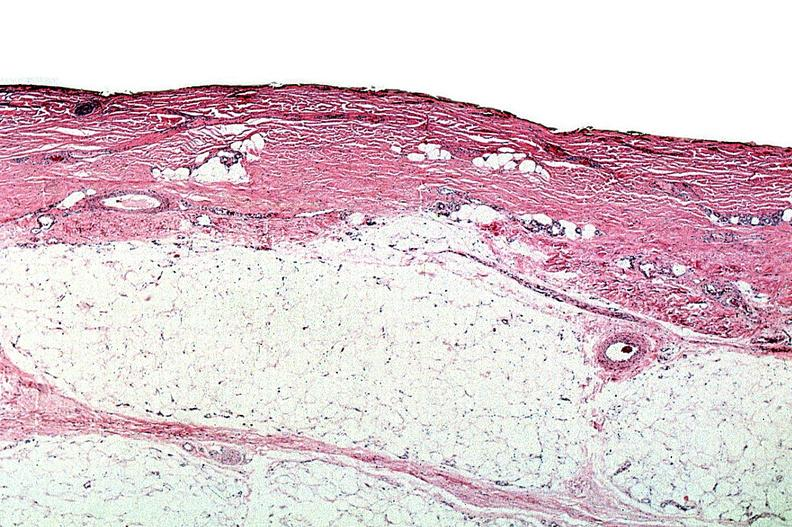what does this image show?
Answer the question using a single word or phrase. Thermal burned skin 